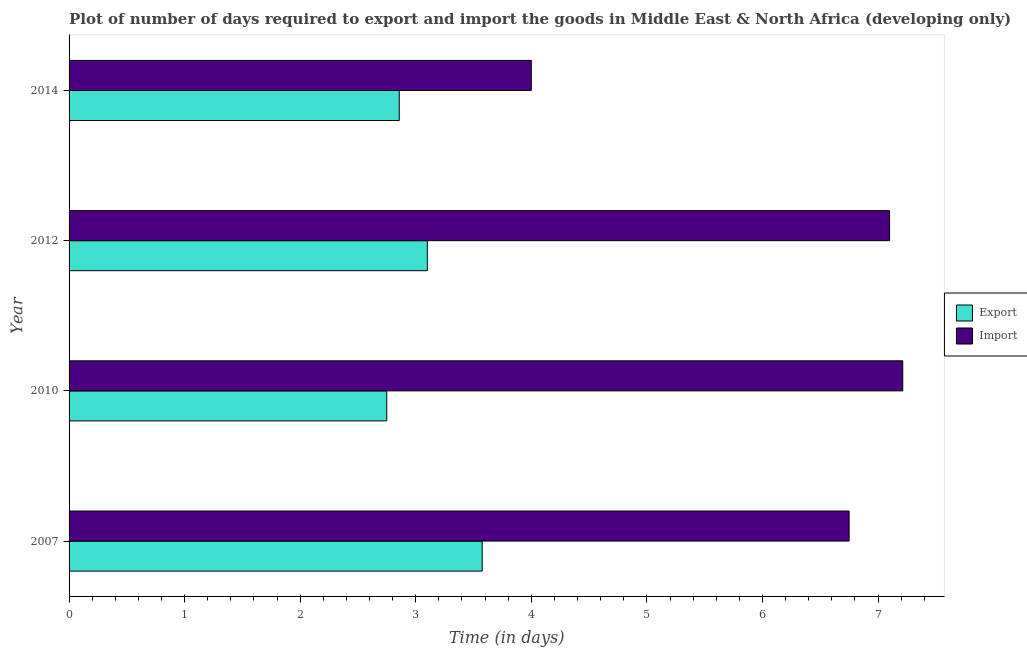How many groups of bars are there?
Make the answer very short. 4. How many bars are there on the 2nd tick from the top?
Provide a short and direct response. 2. What is the time required to import in 2014?
Your answer should be compact. 4. Across all years, what is the maximum time required to export?
Give a very brief answer. 3.58. Across all years, what is the minimum time required to export?
Make the answer very short. 2.75. In which year was the time required to import maximum?
Your response must be concise. 2010. What is the total time required to export in the graph?
Your response must be concise. 12.28. What is the difference between the time required to import in 2010 and that in 2014?
Provide a short and direct response. 3.21. What is the difference between the time required to import in 2014 and the time required to export in 2007?
Give a very brief answer. 0.42. What is the average time required to import per year?
Provide a short and direct response. 6.27. In the year 2010, what is the difference between the time required to import and time required to export?
Provide a short and direct response. 4.46. In how many years, is the time required to import greater than 5.6 days?
Provide a short and direct response. 3. What is the ratio of the time required to export in 2007 to that in 2014?
Your answer should be very brief. 1.25. Is the time required to export in 2010 less than that in 2012?
Your response must be concise. Yes. Is the difference between the time required to export in 2012 and 2014 greater than the difference between the time required to import in 2012 and 2014?
Give a very brief answer. No. What is the difference between the highest and the second highest time required to import?
Keep it short and to the point. 0.11. What is the difference between the highest and the lowest time required to import?
Provide a short and direct response. 3.21. What does the 2nd bar from the top in 2007 represents?
Offer a terse response. Export. What does the 1st bar from the bottom in 2007 represents?
Give a very brief answer. Export. Are all the bars in the graph horizontal?
Give a very brief answer. Yes. What is the difference between two consecutive major ticks on the X-axis?
Keep it short and to the point. 1. Does the graph contain grids?
Keep it short and to the point. No. Where does the legend appear in the graph?
Provide a succinct answer. Center right. What is the title of the graph?
Make the answer very short. Plot of number of days required to export and import the goods in Middle East & North Africa (developing only). What is the label or title of the X-axis?
Offer a terse response. Time (in days). What is the Time (in days) in Export in 2007?
Offer a terse response. 3.58. What is the Time (in days) in Import in 2007?
Your answer should be very brief. 6.75. What is the Time (in days) of Export in 2010?
Your answer should be very brief. 2.75. What is the Time (in days) in Import in 2010?
Keep it short and to the point. 7.21. What is the Time (in days) in Export in 2012?
Your response must be concise. 3.1. What is the Time (in days) in Import in 2012?
Provide a short and direct response. 7.1. What is the Time (in days) in Export in 2014?
Offer a terse response. 2.86. Across all years, what is the maximum Time (in days) of Export?
Offer a very short reply. 3.58. Across all years, what is the maximum Time (in days) in Import?
Your answer should be compact. 7.21. Across all years, what is the minimum Time (in days) in Export?
Provide a short and direct response. 2.75. What is the total Time (in days) of Export in the graph?
Keep it short and to the point. 12.28. What is the total Time (in days) of Import in the graph?
Ensure brevity in your answer.  25.06. What is the difference between the Time (in days) of Export in 2007 and that in 2010?
Ensure brevity in your answer.  0.83. What is the difference between the Time (in days) of Import in 2007 and that in 2010?
Offer a very short reply. -0.46. What is the difference between the Time (in days) of Export in 2007 and that in 2012?
Provide a succinct answer. 0.47. What is the difference between the Time (in days) of Import in 2007 and that in 2012?
Make the answer very short. -0.35. What is the difference between the Time (in days) of Export in 2007 and that in 2014?
Provide a succinct answer. 0.72. What is the difference between the Time (in days) in Import in 2007 and that in 2014?
Your response must be concise. 2.75. What is the difference between the Time (in days) in Export in 2010 and that in 2012?
Your answer should be very brief. -0.35. What is the difference between the Time (in days) in Import in 2010 and that in 2012?
Your response must be concise. 0.11. What is the difference between the Time (in days) in Export in 2010 and that in 2014?
Offer a very short reply. -0.11. What is the difference between the Time (in days) in Import in 2010 and that in 2014?
Your response must be concise. 3.21. What is the difference between the Time (in days) of Export in 2012 and that in 2014?
Provide a short and direct response. 0.24. What is the difference between the Time (in days) of Import in 2012 and that in 2014?
Provide a short and direct response. 3.1. What is the difference between the Time (in days) in Export in 2007 and the Time (in days) in Import in 2010?
Give a very brief answer. -3.64. What is the difference between the Time (in days) in Export in 2007 and the Time (in days) in Import in 2012?
Your answer should be very brief. -3.52. What is the difference between the Time (in days) in Export in 2007 and the Time (in days) in Import in 2014?
Make the answer very short. -0.42. What is the difference between the Time (in days) of Export in 2010 and the Time (in days) of Import in 2012?
Offer a very short reply. -4.35. What is the difference between the Time (in days) in Export in 2010 and the Time (in days) in Import in 2014?
Give a very brief answer. -1.25. What is the difference between the Time (in days) of Export in 2012 and the Time (in days) of Import in 2014?
Provide a succinct answer. -0.9. What is the average Time (in days) in Export per year?
Keep it short and to the point. 3.07. What is the average Time (in days) of Import per year?
Make the answer very short. 6.27. In the year 2007, what is the difference between the Time (in days) in Export and Time (in days) in Import?
Your response must be concise. -3.17. In the year 2010, what is the difference between the Time (in days) of Export and Time (in days) of Import?
Offer a very short reply. -4.46. In the year 2012, what is the difference between the Time (in days) of Export and Time (in days) of Import?
Keep it short and to the point. -4. In the year 2014, what is the difference between the Time (in days) of Export and Time (in days) of Import?
Make the answer very short. -1.14. What is the ratio of the Time (in days) in Export in 2007 to that in 2010?
Offer a very short reply. 1.3. What is the ratio of the Time (in days) in Import in 2007 to that in 2010?
Provide a succinct answer. 0.94. What is the ratio of the Time (in days) in Export in 2007 to that in 2012?
Your answer should be very brief. 1.15. What is the ratio of the Time (in days) of Import in 2007 to that in 2012?
Keep it short and to the point. 0.95. What is the ratio of the Time (in days) in Export in 2007 to that in 2014?
Your response must be concise. 1.25. What is the ratio of the Time (in days) of Import in 2007 to that in 2014?
Offer a terse response. 1.69. What is the ratio of the Time (in days) in Export in 2010 to that in 2012?
Keep it short and to the point. 0.89. What is the ratio of the Time (in days) of Import in 2010 to that in 2012?
Keep it short and to the point. 1.02. What is the ratio of the Time (in days) in Export in 2010 to that in 2014?
Provide a succinct answer. 0.96. What is the ratio of the Time (in days) of Import in 2010 to that in 2014?
Your answer should be compact. 1.8. What is the ratio of the Time (in days) of Export in 2012 to that in 2014?
Provide a succinct answer. 1.08. What is the ratio of the Time (in days) in Import in 2012 to that in 2014?
Keep it short and to the point. 1.77. What is the difference between the highest and the second highest Time (in days) of Export?
Keep it short and to the point. 0.47. What is the difference between the highest and the second highest Time (in days) in Import?
Provide a succinct answer. 0.11. What is the difference between the highest and the lowest Time (in days) of Export?
Ensure brevity in your answer.  0.83. What is the difference between the highest and the lowest Time (in days) in Import?
Make the answer very short. 3.21. 